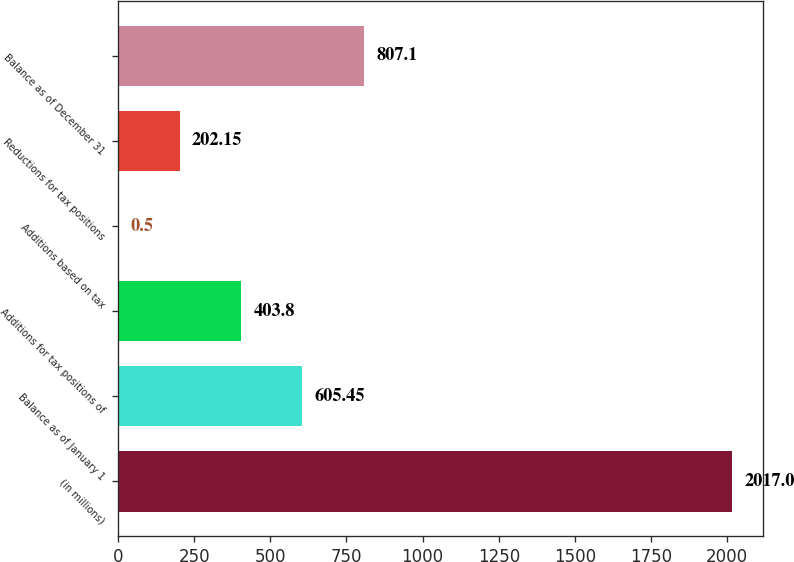Convert chart to OTSL. <chart><loc_0><loc_0><loc_500><loc_500><bar_chart><fcel>(in millions)<fcel>Balance as of January 1<fcel>Additions for tax positions of<fcel>Additions based on tax<fcel>Reductions for tax positions<fcel>Balance as of December 31<nl><fcel>2017<fcel>605.45<fcel>403.8<fcel>0.5<fcel>202.15<fcel>807.1<nl></chart> 